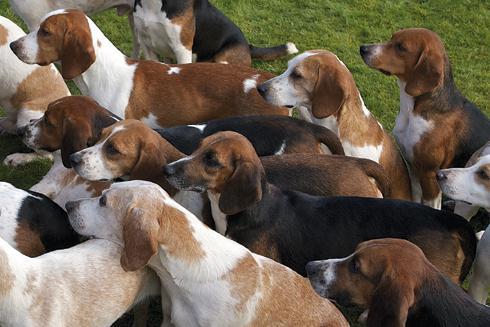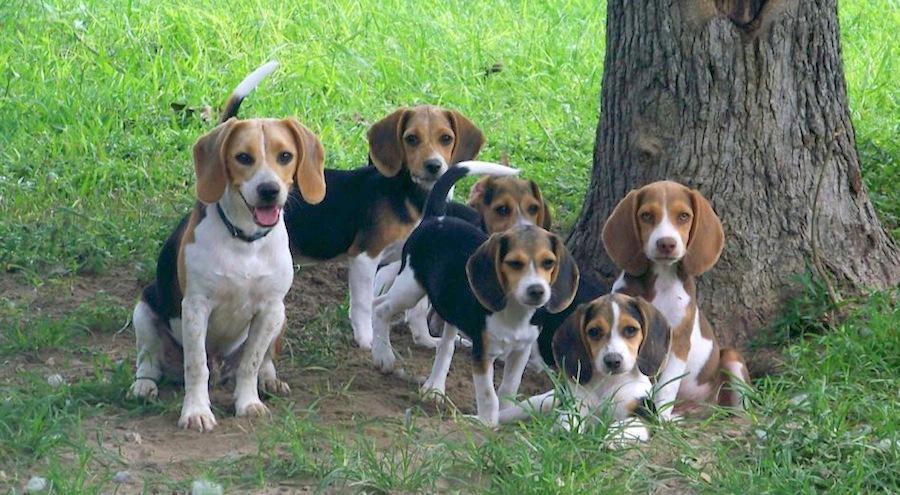The first image is the image on the left, the second image is the image on the right. Examine the images to the left and right. Is the description "An image contains exactly one dog, a beagle puppy that is sitting on green grass." accurate? Answer yes or no. No. The first image is the image on the left, the second image is the image on the right. Analyze the images presented: Is the assertion "The right image contains no more than three dogs." valid? Answer yes or no. No. 